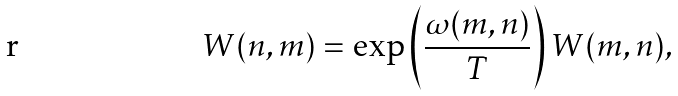Convert formula to latex. <formula><loc_0><loc_0><loc_500><loc_500>W ( n , m ) = \exp \left ( \frac { \omega ( m , n ) } { T } \right ) W ( m , n ) ,</formula> 